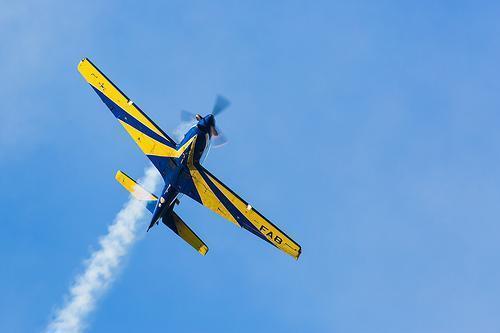How many propellers are there?
Give a very brief answer. 1. 